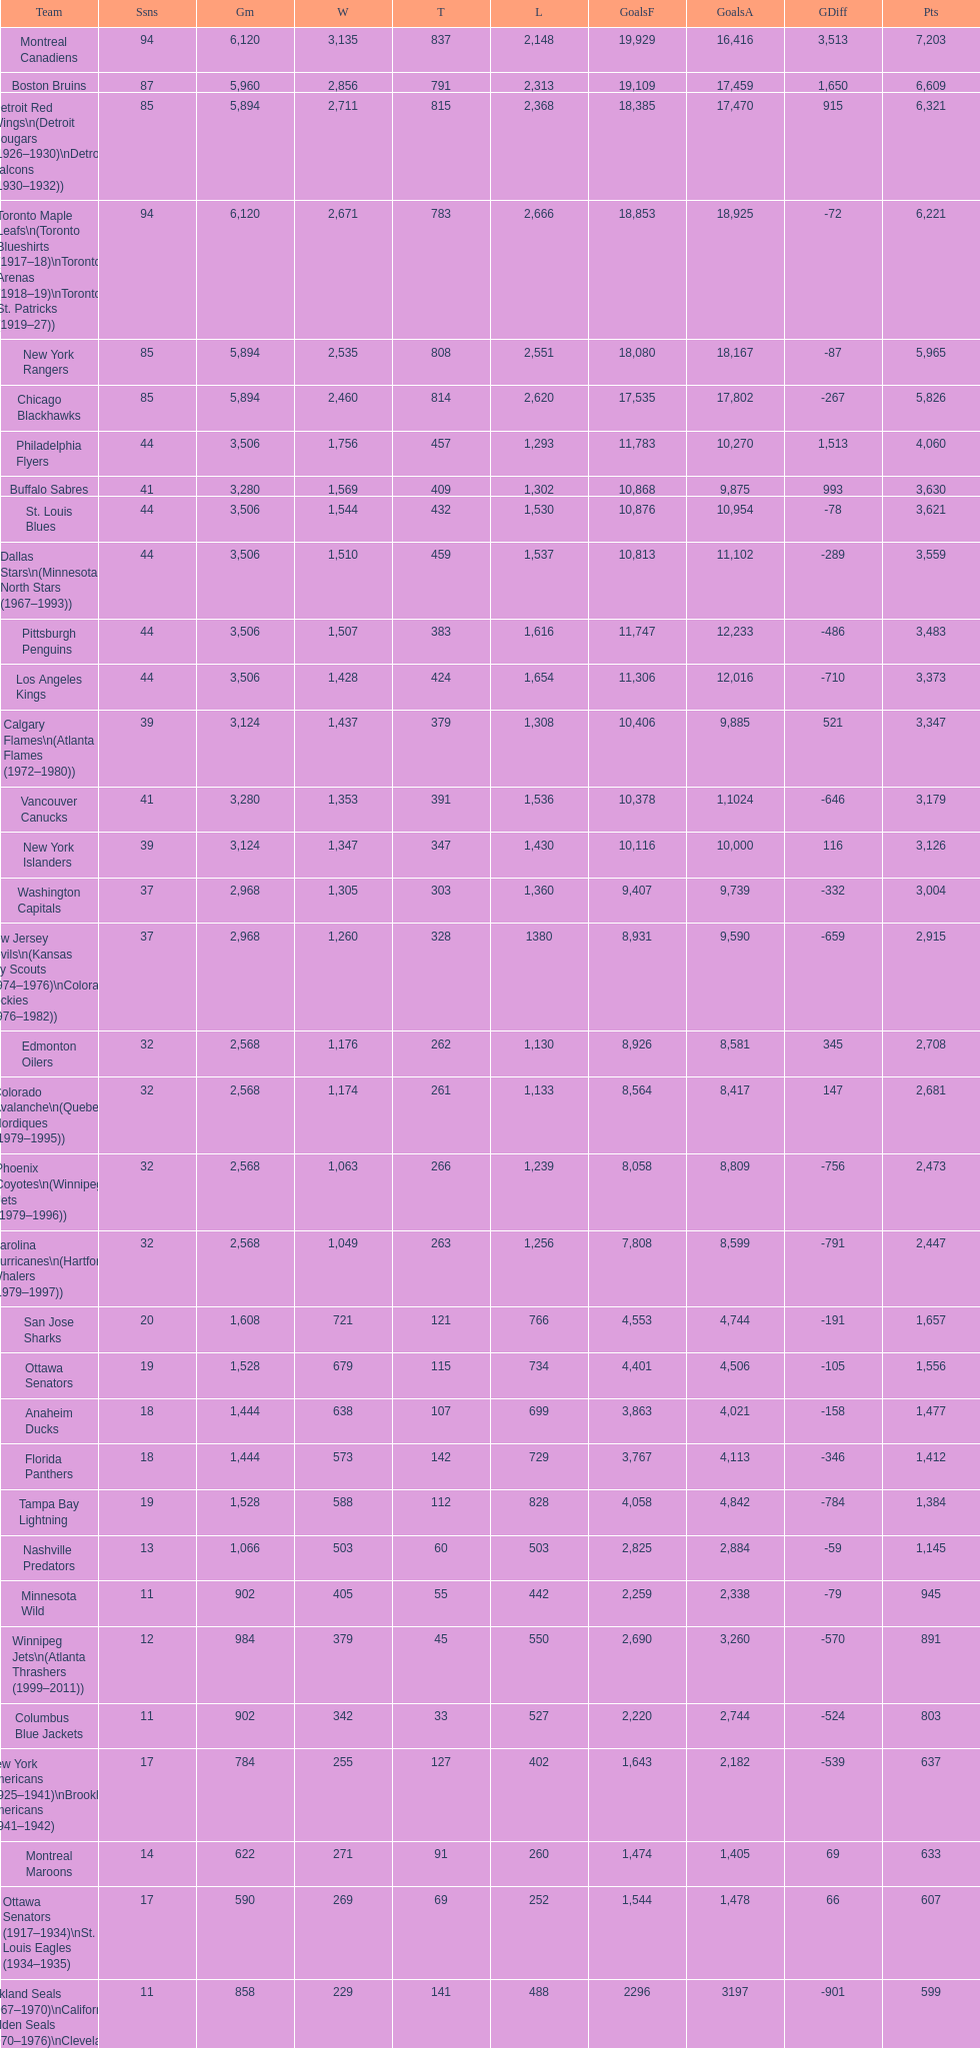Which team played the same amount of seasons as the canadiens? Toronto Maple Leafs. 